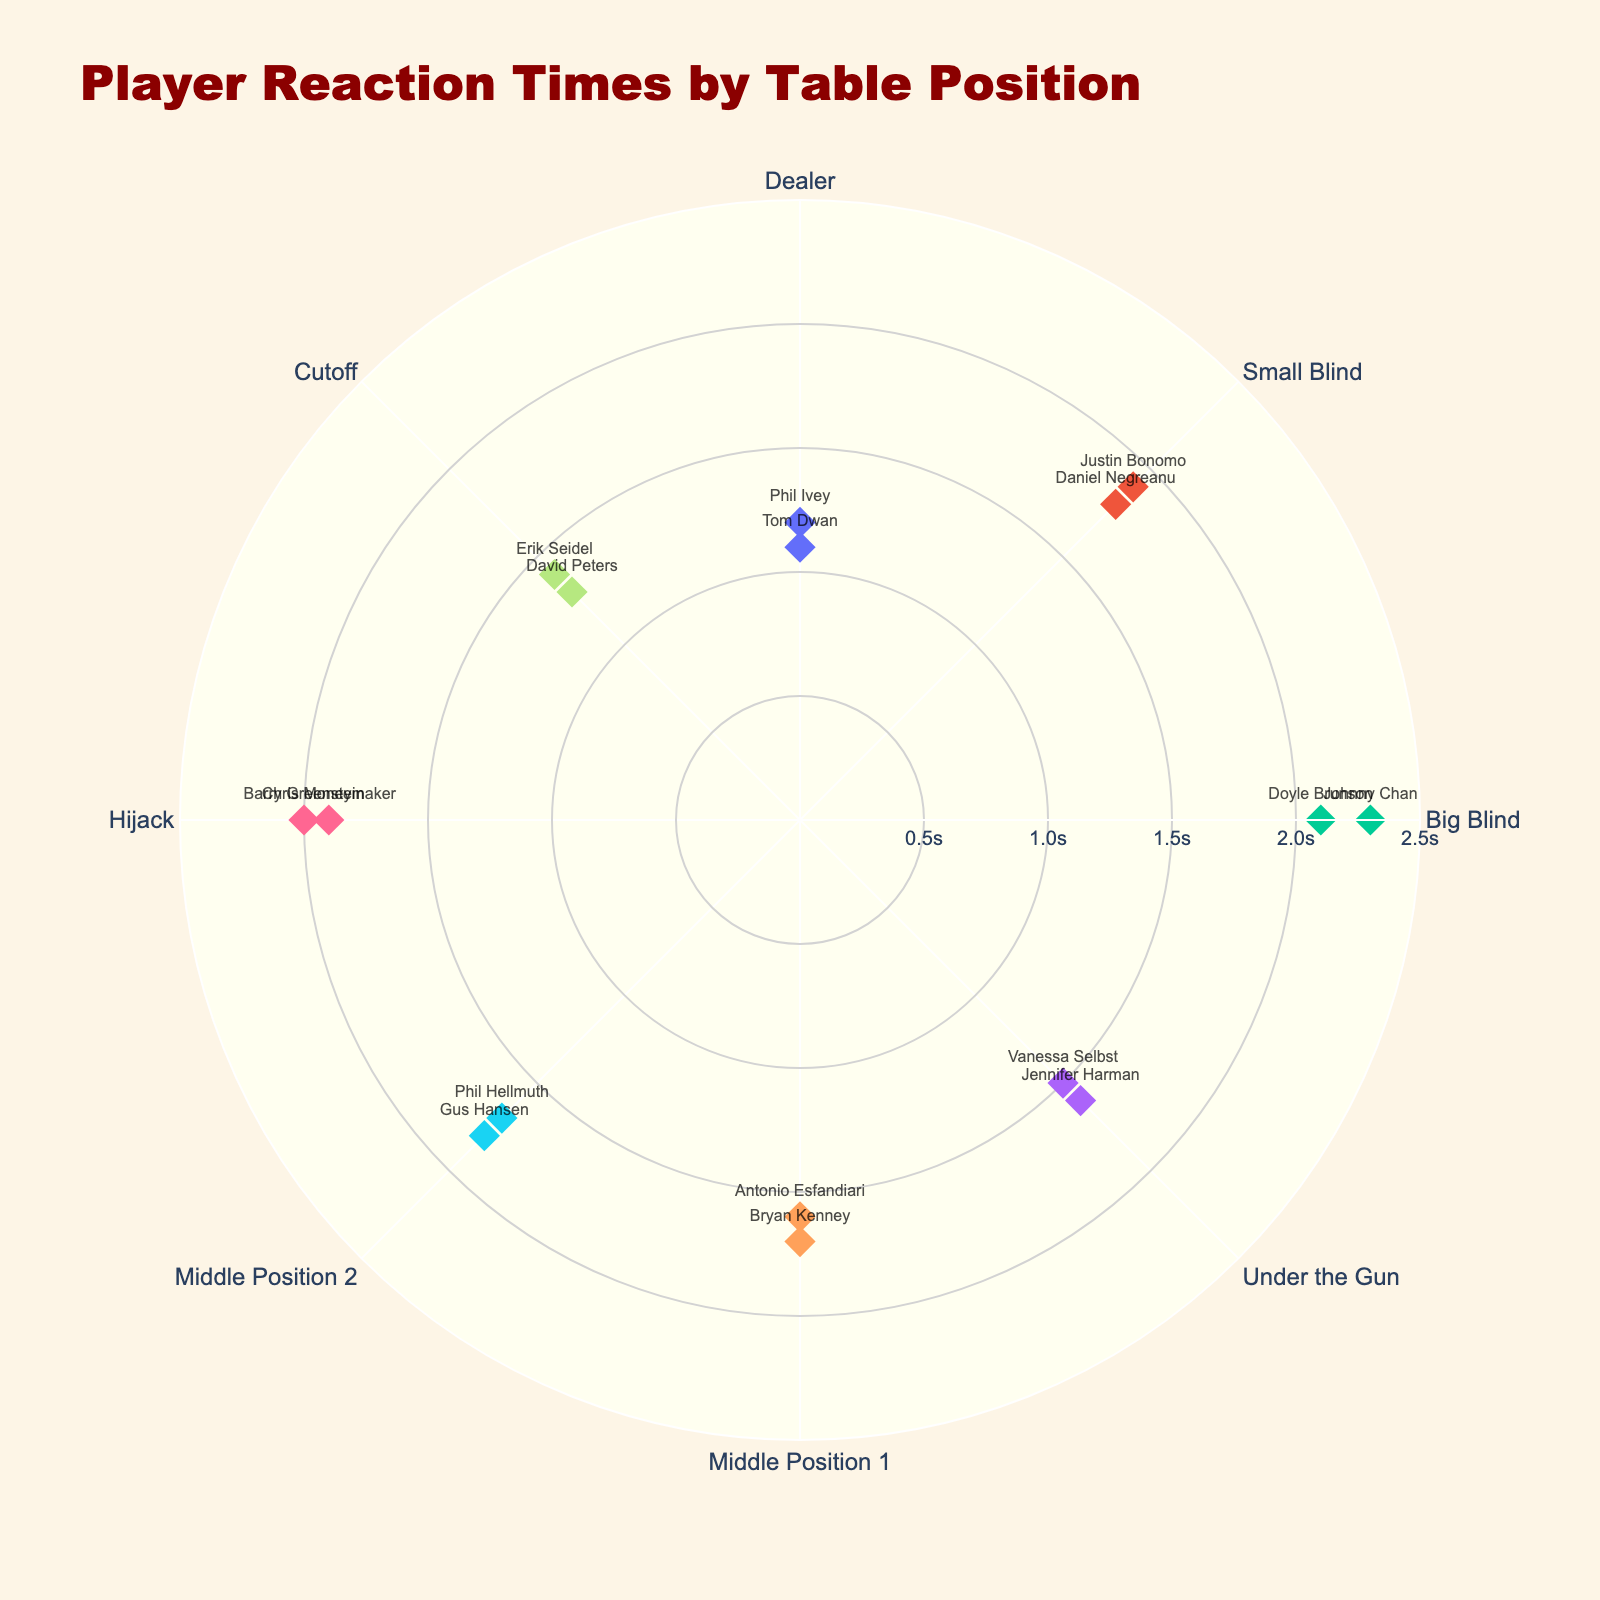What's the title of the figure? The title of the figure is indicated at the top and reads "Player Reaction Times by Table Position".
Answer: Player Reaction Times by Table Position What is the maximum reaction time displayed in the chart? The chart shows the reaction times as radial values. The furthest marker from the center, indicating the maximum reaction time, is at 2.3 seconds.
Answer: 2.3 seconds Which player has the quickest reaction time among all positions? By examining the markers and the accompanying player names, Tom Dwan at the Dealer position has the smallest radial distance, indicating the quickest reaction time at 1.1 seconds.
Answer: Tom Dwan What is the average reaction time for players in the Hijack position? There are two players in the Hijack position: Chris Moneymaker (1.9s) and Barry Greenstein (2.0s). The average is calculated as (1.9 + 2.0) / 2.
Answer: 1.95 seconds Who has the longest reaction time in the Big Blind position? The Big Blind position has two markers, one at 2.1 seconds (Doyle Brunson) and one at 2.3 seconds (Johnny Chan). Johnny Chan has the longest reaction time in this position.
Answer: Johnny Chan Which position shows the most variation in reaction times among players? By observing the scatter plot, the Small Blind position has reaction times of 1.8 seconds (Daniel Negreanu) and 1.9 seconds (Justin Bonomo), indicating a low variation. Contrastingly, the Big Blind position has reaction times from 2.1 seconds to 2.3 seconds. Similarly, the Dealer position ranges from 1.1 seconds to 1.2 seconds. However, the positions showing the greater variation are the Big Blind and Dealer, with the Big Blind having a 0.2-second range compared to the Dealer's 0.1-second range.
Answer: Big Blind What is the median reaction time for the Middle Position 1? The reaction times for Middle Position 1 are 1.6 seconds (Antonio Esfandiari) and 1.7 seconds (Bryan Kenney). The median is calculated by ordering them (1.6, 1.7) and selecting the middle value, which is 1.65 seconds.
Answer: 1.65 seconds Among the Dealer, Small Blind, and Big Blind positions, which has the highest average reaction time? The Dealer position has reaction times of 1.2 and 1.1 (average 1.15), the Small Blind has reaction times of 1.8 and 1.9 (average 1.85), and the Big Blind has reaction times of 2.1 and 2.3 (average 2.2). Comparing these averages, the Big Blind has the highest at 2.2 seconds.
Answer: Big Blind What is the difference in reaction time between the quickest and slowest players in the chart? The quickest reaction time is Tom Dwan with 1.1 seconds, and the slowest is Johnny Chan with 2.3 seconds. The difference is calculated as 2.3 - 1.1.
Answer: 1.2 seconds Which two consecutive positions on the plot have the smallest difference in average reaction times? Calculate the average reaction times for each position and compare the consecutive positions around the polar chart. Dealer averages 1.15s, Small Blind 1.85s, Big Blind 2.2s, Under the Gun 1.55s, Middle Position 1 1.65s, Middle Position 2 1.75s, Hijack 1.95s, and Cutoff 1.35s. The smallest difference is between Middle Position 1 (1.65s) and Middle Position 2 (1.75s) with a 0.1-second difference.
Answer: Middle Position 1 and Middle Position 2 